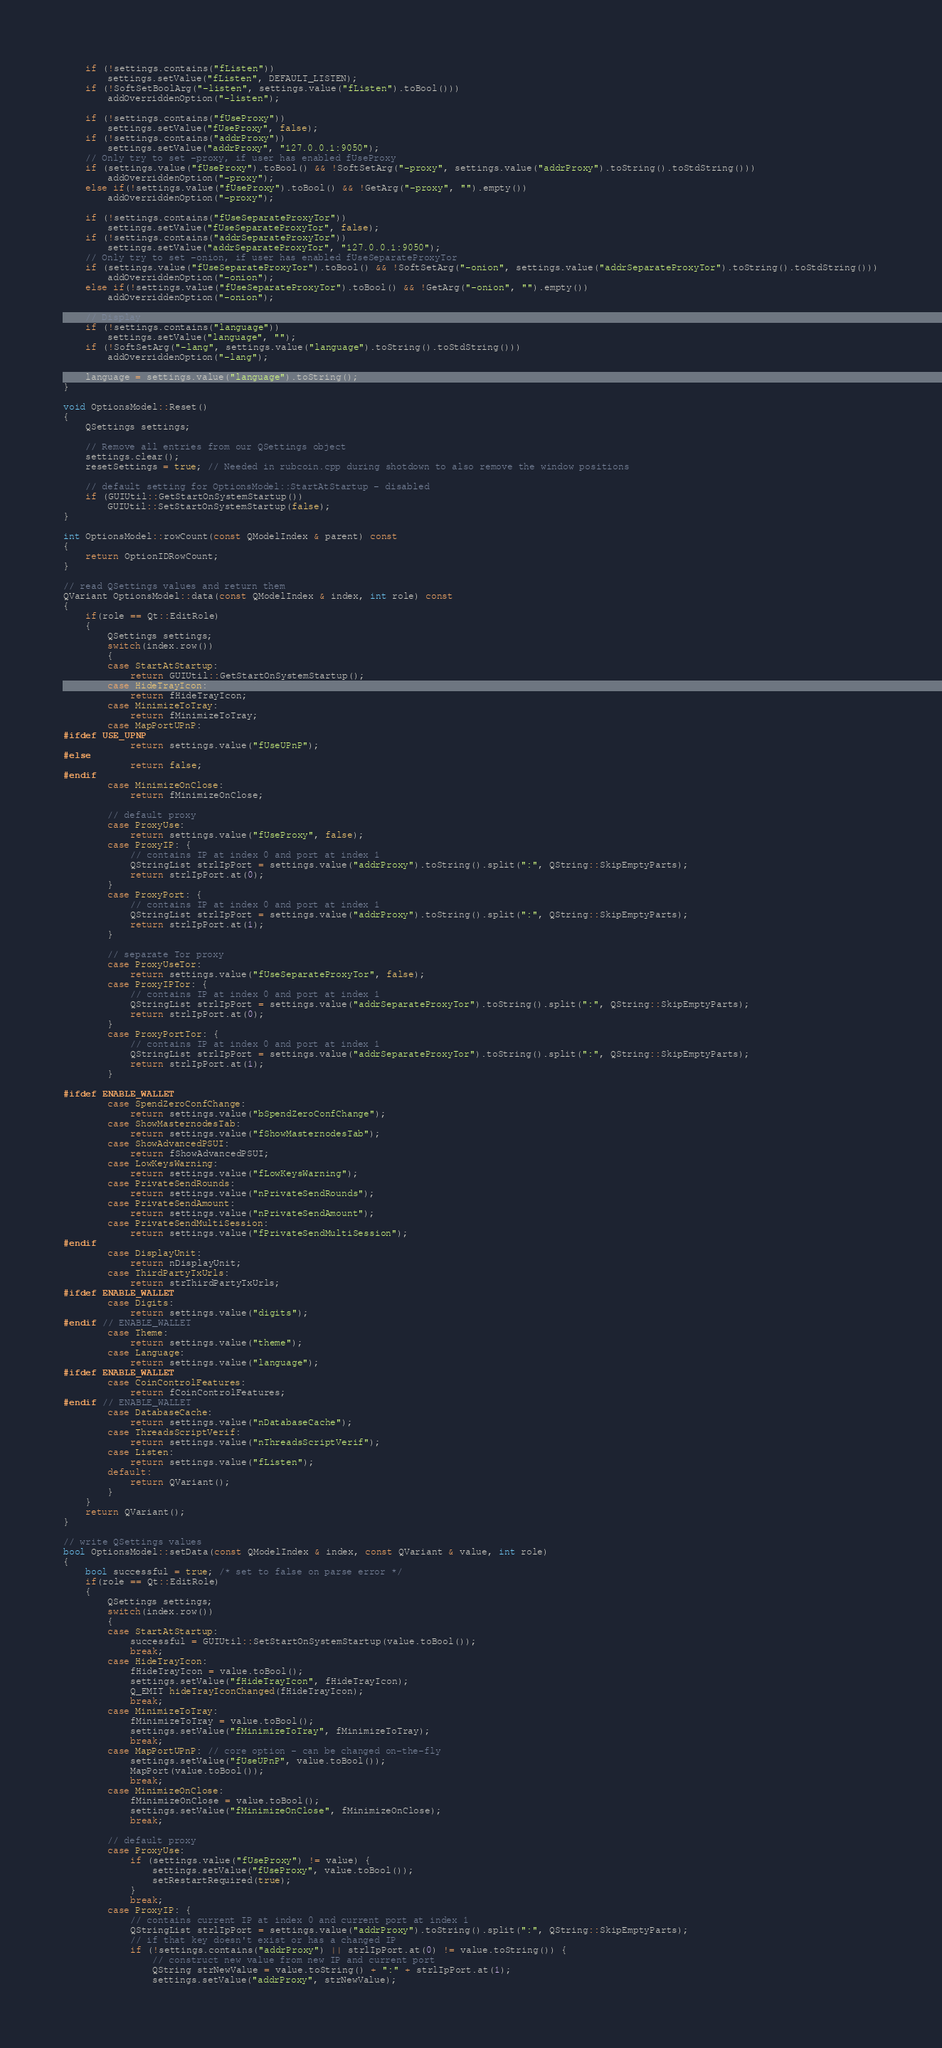Convert code to text. <code><loc_0><loc_0><loc_500><loc_500><_C++_>
    if (!settings.contains("fListen"))
        settings.setValue("fListen", DEFAULT_LISTEN);
    if (!SoftSetBoolArg("-listen", settings.value("fListen").toBool()))
        addOverriddenOption("-listen");

    if (!settings.contains("fUseProxy"))
        settings.setValue("fUseProxy", false);
    if (!settings.contains("addrProxy"))
        settings.setValue("addrProxy", "127.0.0.1:9050");
    // Only try to set -proxy, if user has enabled fUseProxy
    if (settings.value("fUseProxy").toBool() && !SoftSetArg("-proxy", settings.value("addrProxy").toString().toStdString()))
        addOverriddenOption("-proxy");
    else if(!settings.value("fUseProxy").toBool() && !GetArg("-proxy", "").empty())
        addOverriddenOption("-proxy");

    if (!settings.contains("fUseSeparateProxyTor"))
        settings.setValue("fUseSeparateProxyTor", false);
    if (!settings.contains("addrSeparateProxyTor"))
        settings.setValue("addrSeparateProxyTor", "127.0.0.1:9050");
    // Only try to set -onion, if user has enabled fUseSeparateProxyTor
    if (settings.value("fUseSeparateProxyTor").toBool() && !SoftSetArg("-onion", settings.value("addrSeparateProxyTor").toString().toStdString()))
        addOverriddenOption("-onion");
    else if(!settings.value("fUseSeparateProxyTor").toBool() && !GetArg("-onion", "").empty())
        addOverriddenOption("-onion");

    // Display
    if (!settings.contains("language"))
        settings.setValue("language", "");
    if (!SoftSetArg("-lang", settings.value("language").toString().toStdString()))
        addOverriddenOption("-lang");

    language = settings.value("language").toString();
}

void OptionsModel::Reset()
{
    QSettings settings;

    // Remove all entries from our QSettings object
    settings.clear();
    resetSettings = true; // Needed in rubcoin.cpp during shotdown to also remove the window positions

    // default setting for OptionsModel::StartAtStartup - disabled
    if (GUIUtil::GetStartOnSystemStartup())
        GUIUtil::SetStartOnSystemStartup(false);
}

int OptionsModel::rowCount(const QModelIndex & parent) const
{
    return OptionIDRowCount;
}

// read QSettings values and return them
QVariant OptionsModel::data(const QModelIndex & index, int role) const
{
    if(role == Qt::EditRole)
    {
        QSettings settings;
        switch(index.row())
        {
        case StartAtStartup:
            return GUIUtil::GetStartOnSystemStartup();
        case HideTrayIcon:
            return fHideTrayIcon;
        case MinimizeToTray:
            return fMinimizeToTray;
        case MapPortUPnP:
#ifdef USE_UPNP
            return settings.value("fUseUPnP");
#else
            return false;
#endif
        case MinimizeOnClose:
            return fMinimizeOnClose;

        // default proxy
        case ProxyUse:
            return settings.value("fUseProxy", false);
        case ProxyIP: {
            // contains IP at index 0 and port at index 1
            QStringList strlIpPort = settings.value("addrProxy").toString().split(":", QString::SkipEmptyParts);
            return strlIpPort.at(0);
        }
        case ProxyPort: {
            // contains IP at index 0 and port at index 1
            QStringList strlIpPort = settings.value("addrProxy").toString().split(":", QString::SkipEmptyParts);
            return strlIpPort.at(1);
        }

        // separate Tor proxy
        case ProxyUseTor:
            return settings.value("fUseSeparateProxyTor", false);
        case ProxyIPTor: {
            // contains IP at index 0 and port at index 1
            QStringList strlIpPort = settings.value("addrSeparateProxyTor").toString().split(":", QString::SkipEmptyParts);
            return strlIpPort.at(0);
        }
        case ProxyPortTor: {
            // contains IP at index 0 and port at index 1
            QStringList strlIpPort = settings.value("addrSeparateProxyTor").toString().split(":", QString::SkipEmptyParts);
            return strlIpPort.at(1);
        }

#ifdef ENABLE_WALLET
        case SpendZeroConfChange:
            return settings.value("bSpendZeroConfChange");
        case ShowMasternodesTab:
            return settings.value("fShowMasternodesTab");
        case ShowAdvancedPSUI:
            return fShowAdvancedPSUI;
        case LowKeysWarning:
            return settings.value("fLowKeysWarning");
        case PrivateSendRounds:
            return settings.value("nPrivateSendRounds");
        case PrivateSendAmount:
            return settings.value("nPrivateSendAmount");
        case PrivateSendMultiSession:
            return settings.value("fPrivateSendMultiSession");
#endif
        case DisplayUnit:
            return nDisplayUnit;
        case ThirdPartyTxUrls:
            return strThirdPartyTxUrls;
#ifdef ENABLE_WALLET
        case Digits:
            return settings.value("digits");
#endif // ENABLE_WALLET
        case Theme:
            return settings.value("theme");
        case Language:
            return settings.value("language");
#ifdef ENABLE_WALLET
        case CoinControlFeatures:
            return fCoinControlFeatures;
#endif // ENABLE_WALLET
        case DatabaseCache:
            return settings.value("nDatabaseCache");
        case ThreadsScriptVerif:
            return settings.value("nThreadsScriptVerif");
        case Listen:
            return settings.value("fListen");
        default:
            return QVariant();
        }
    }
    return QVariant();
}

// write QSettings values
bool OptionsModel::setData(const QModelIndex & index, const QVariant & value, int role)
{
    bool successful = true; /* set to false on parse error */
    if(role == Qt::EditRole)
    {
        QSettings settings;
        switch(index.row())
        {
        case StartAtStartup:
            successful = GUIUtil::SetStartOnSystemStartup(value.toBool());
            break;
        case HideTrayIcon:
            fHideTrayIcon = value.toBool();
            settings.setValue("fHideTrayIcon", fHideTrayIcon);
    		Q_EMIT hideTrayIconChanged(fHideTrayIcon);
            break;
        case MinimizeToTray:
            fMinimizeToTray = value.toBool();
            settings.setValue("fMinimizeToTray", fMinimizeToTray);
            break;
        case MapPortUPnP: // core option - can be changed on-the-fly
            settings.setValue("fUseUPnP", value.toBool());
            MapPort(value.toBool());
            break;
        case MinimizeOnClose:
            fMinimizeOnClose = value.toBool();
            settings.setValue("fMinimizeOnClose", fMinimizeOnClose);
            break;

        // default proxy
        case ProxyUse:
            if (settings.value("fUseProxy") != value) {
                settings.setValue("fUseProxy", value.toBool());
                setRestartRequired(true);
            }
            break;
        case ProxyIP: {
            // contains current IP at index 0 and current port at index 1
            QStringList strlIpPort = settings.value("addrProxy").toString().split(":", QString::SkipEmptyParts);
            // if that key doesn't exist or has a changed IP
            if (!settings.contains("addrProxy") || strlIpPort.at(0) != value.toString()) {
                // construct new value from new IP and current port
                QString strNewValue = value.toString() + ":" + strlIpPort.at(1);
                settings.setValue("addrProxy", strNewValue);</code> 